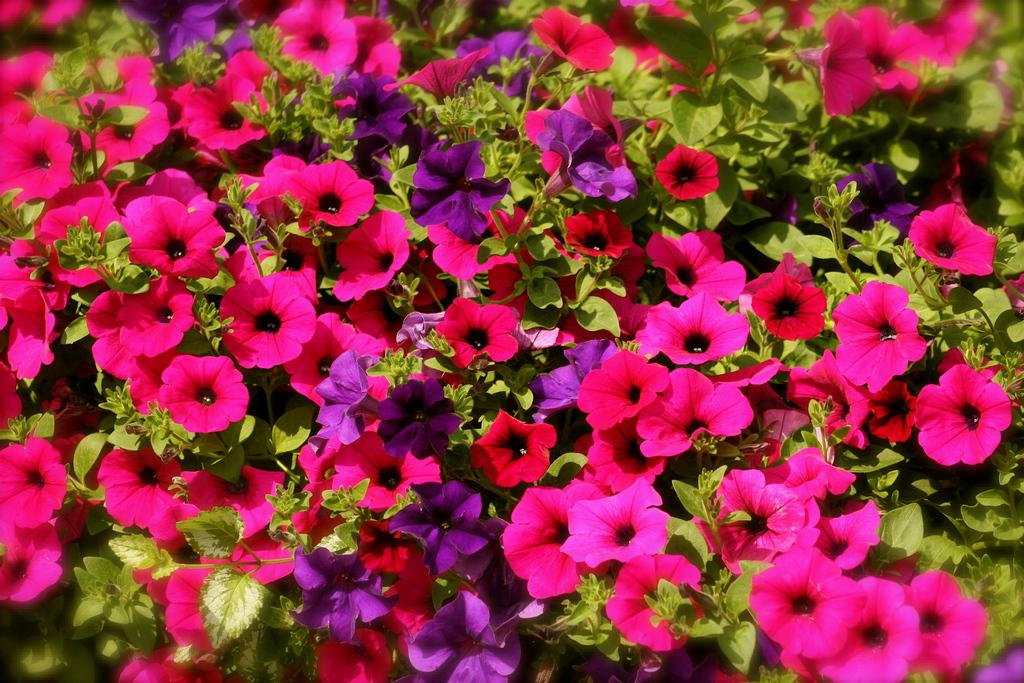What is the main subject of the image? The main subject of the image is a group of flowers. What are the flowers connected to? The flowers are associated with plants. What colors can be seen among the flowers in the image? Some flowers are pink in color, and some are blue in color. How many cats are lying on the quilt in the image? There are no cats or quilts present in the image; it features a group of flowers. What emotion does the disgusting smell of the flowers evoke in the image? There is no mention of any smell, let alone a disgusting one, in the image. The image only shows a group of flowers with pink and blue colors. 